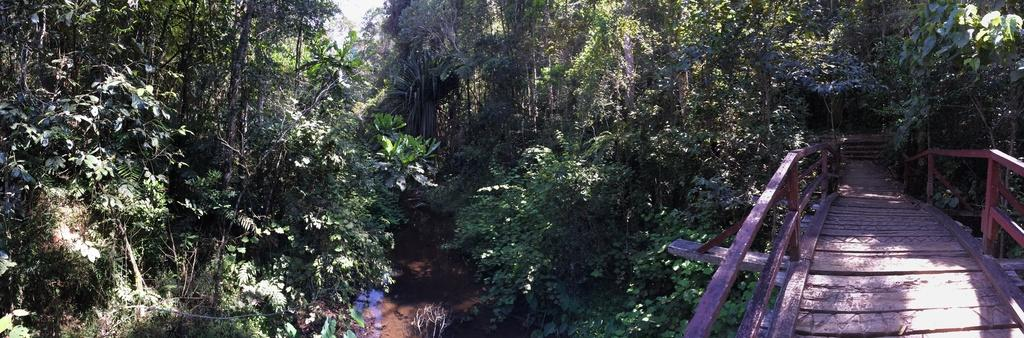What type of vegetation can be seen in the image? There are trees in the image. What structure is present in the image? There is a bridge visible in the image. Where is the bridge located in relation to the trees? The bridge is located between the trees. How many fowl are perched on the bridge in the image? There are no fowl present in the image; it only features trees and a bridge. What type of bed can be seen in the image? There is no bed present in the image. 